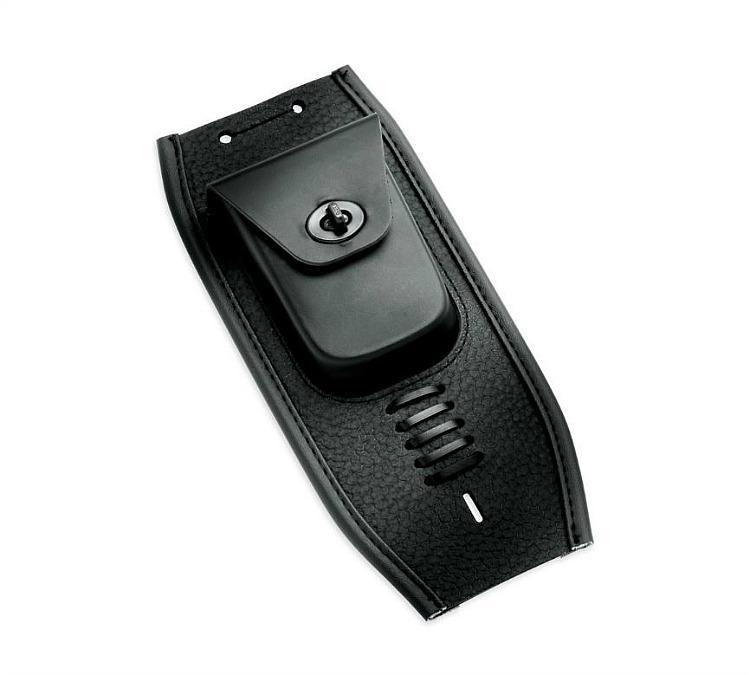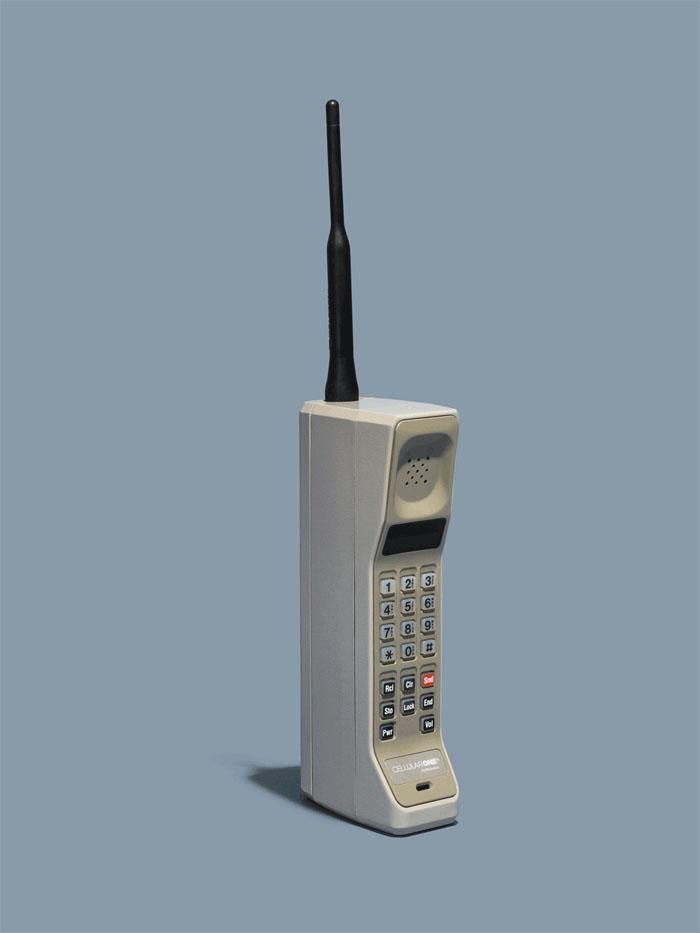The first image is the image on the left, the second image is the image on the right. Given the left and right images, does the statement "There are three objects." hold true? Answer yes or no. No. The first image is the image on the left, the second image is the image on the right. Analyze the images presented: Is the assertion "One of the phones is connected to an old fashioned handset." valid? Answer yes or no. No. 